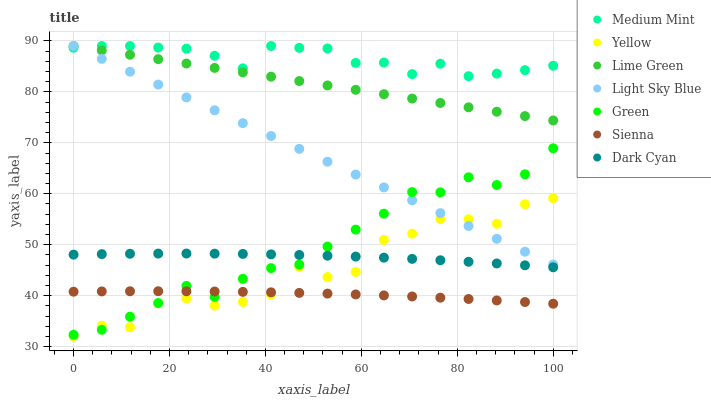Does Sienna have the minimum area under the curve?
Answer yes or no. Yes. Does Medium Mint have the maximum area under the curve?
Answer yes or no. Yes. Does Yellow have the minimum area under the curve?
Answer yes or no. No. Does Yellow have the maximum area under the curve?
Answer yes or no. No. Is Light Sky Blue the smoothest?
Answer yes or no. Yes. Is Yellow the roughest?
Answer yes or no. Yes. Is Sienna the smoothest?
Answer yes or no. No. Is Sienna the roughest?
Answer yes or no. No. Does Yellow have the lowest value?
Answer yes or no. Yes. Does Sienna have the lowest value?
Answer yes or no. No. Does Lime Green have the highest value?
Answer yes or no. Yes. Does Yellow have the highest value?
Answer yes or no. No. Is Dark Cyan less than Medium Mint?
Answer yes or no. Yes. Is Medium Mint greater than Yellow?
Answer yes or no. Yes. Does Yellow intersect Sienna?
Answer yes or no. Yes. Is Yellow less than Sienna?
Answer yes or no. No. Is Yellow greater than Sienna?
Answer yes or no. No. Does Dark Cyan intersect Medium Mint?
Answer yes or no. No. 